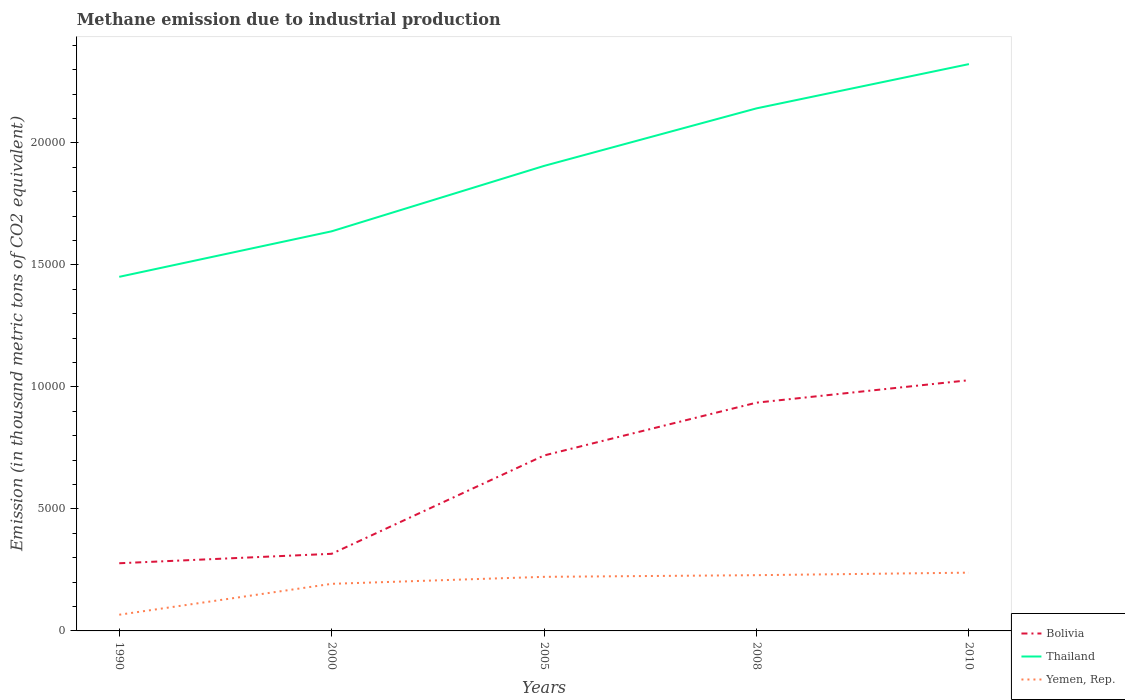Across all years, what is the maximum amount of methane emitted in Bolivia?
Provide a short and direct response. 2773.8. In which year was the amount of methane emitted in Thailand maximum?
Provide a short and direct response. 1990. What is the total amount of methane emitted in Thailand in the graph?
Keep it short and to the point. -1813.8. What is the difference between the highest and the second highest amount of methane emitted in Yemen, Rep.?
Provide a short and direct response. 1724.3. How many lines are there?
Your answer should be very brief. 3. How many years are there in the graph?
Your answer should be compact. 5. What is the difference between two consecutive major ticks on the Y-axis?
Keep it short and to the point. 5000. Does the graph contain any zero values?
Provide a succinct answer. No. Where does the legend appear in the graph?
Provide a short and direct response. Bottom right. How are the legend labels stacked?
Keep it short and to the point. Vertical. What is the title of the graph?
Your answer should be very brief. Methane emission due to industrial production. Does "Malawi" appear as one of the legend labels in the graph?
Offer a terse response. No. What is the label or title of the Y-axis?
Keep it short and to the point. Emission (in thousand metric tons of CO2 equivalent). What is the Emission (in thousand metric tons of CO2 equivalent) in Bolivia in 1990?
Give a very brief answer. 2773.8. What is the Emission (in thousand metric tons of CO2 equivalent) of Thailand in 1990?
Provide a succinct answer. 1.45e+04. What is the Emission (in thousand metric tons of CO2 equivalent) in Yemen, Rep. in 1990?
Ensure brevity in your answer.  664. What is the Emission (in thousand metric tons of CO2 equivalent) of Bolivia in 2000?
Make the answer very short. 3160.9. What is the Emission (in thousand metric tons of CO2 equivalent) of Thailand in 2000?
Your answer should be compact. 1.64e+04. What is the Emission (in thousand metric tons of CO2 equivalent) in Yemen, Rep. in 2000?
Offer a very short reply. 1930.1. What is the Emission (in thousand metric tons of CO2 equivalent) in Bolivia in 2005?
Keep it short and to the point. 7191.7. What is the Emission (in thousand metric tons of CO2 equivalent) in Thailand in 2005?
Your answer should be very brief. 1.91e+04. What is the Emission (in thousand metric tons of CO2 equivalent) of Yemen, Rep. in 2005?
Make the answer very short. 2216.9. What is the Emission (in thousand metric tons of CO2 equivalent) of Bolivia in 2008?
Give a very brief answer. 9356.3. What is the Emission (in thousand metric tons of CO2 equivalent) in Thailand in 2008?
Keep it short and to the point. 2.14e+04. What is the Emission (in thousand metric tons of CO2 equivalent) in Yemen, Rep. in 2008?
Ensure brevity in your answer.  2284.9. What is the Emission (in thousand metric tons of CO2 equivalent) in Bolivia in 2010?
Ensure brevity in your answer.  1.03e+04. What is the Emission (in thousand metric tons of CO2 equivalent) of Thailand in 2010?
Your answer should be compact. 2.32e+04. What is the Emission (in thousand metric tons of CO2 equivalent) in Yemen, Rep. in 2010?
Your response must be concise. 2388.3. Across all years, what is the maximum Emission (in thousand metric tons of CO2 equivalent) of Bolivia?
Keep it short and to the point. 1.03e+04. Across all years, what is the maximum Emission (in thousand metric tons of CO2 equivalent) in Thailand?
Keep it short and to the point. 2.32e+04. Across all years, what is the maximum Emission (in thousand metric tons of CO2 equivalent) in Yemen, Rep.?
Keep it short and to the point. 2388.3. Across all years, what is the minimum Emission (in thousand metric tons of CO2 equivalent) in Bolivia?
Provide a short and direct response. 2773.8. Across all years, what is the minimum Emission (in thousand metric tons of CO2 equivalent) of Thailand?
Keep it short and to the point. 1.45e+04. Across all years, what is the minimum Emission (in thousand metric tons of CO2 equivalent) of Yemen, Rep.?
Your answer should be very brief. 664. What is the total Emission (in thousand metric tons of CO2 equivalent) in Bolivia in the graph?
Ensure brevity in your answer.  3.28e+04. What is the total Emission (in thousand metric tons of CO2 equivalent) in Thailand in the graph?
Provide a short and direct response. 9.46e+04. What is the total Emission (in thousand metric tons of CO2 equivalent) in Yemen, Rep. in the graph?
Offer a very short reply. 9484.2. What is the difference between the Emission (in thousand metric tons of CO2 equivalent) of Bolivia in 1990 and that in 2000?
Provide a short and direct response. -387.1. What is the difference between the Emission (in thousand metric tons of CO2 equivalent) of Thailand in 1990 and that in 2000?
Keep it short and to the point. -1865.4. What is the difference between the Emission (in thousand metric tons of CO2 equivalent) in Yemen, Rep. in 1990 and that in 2000?
Your answer should be compact. -1266.1. What is the difference between the Emission (in thousand metric tons of CO2 equivalent) of Bolivia in 1990 and that in 2005?
Offer a terse response. -4417.9. What is the difference between the Emission (in thousand metric tons of CO2 equivalent) in Thailand in 1990 and that in 2005?
Offer a terse response. -4546.4. What is the difference between the Emission (in thousand metric tons of CO2 equivalent) in Yemen, Rep. in 1990 and that in 2005?
Keep it short and to the point. -1552.9. What is the difference between the Emission (in thousand metric tons of CO2 equivalent) of Bolivia in 1990 and that in 2008?
Your answer should be compact. -6582.5. What is the difference between the Emission (in thousand metric tons of CO2 equivalent) of Thailand in 1990 and that in 2008?
Make the answer very short. -6904.8. What is the difference between the Emission (in thousand metric tons of CO2 equivalent) of Yemen, Rep. in 1990 and that in 2008?
Provide a short and direct response. -1620.9. What is the difference between the Emission (in thousand metric tons of CO2 equivalent) in Bolivia in 1990 and that in 2010?
Provide a succinct answer. -7502.2. What is the difference between the Emission (in thousand metric tons of CO2 equivalent) in Thailand in 1990 and that in 2010?
Your response must be concise. -8718.6. What is the difference between the Emission (in thousand metric tons of CO2 equivalent) in Yemen, Rep. in 1990 and that in 2010?
Ensure brevity in your answer.  -1724.3. What is the difference between the Emission (in thousand metric tons of CO2 equivalent) of Bolivia in 2000 and that in 2005?
Your answer should be very brief. -4030.8. What is the difference between the Emission (in thousand metric tons of CO2 equivalent) of Thailand in 2000 and that in 2005?
Provide a short and direct response. -2681. What is the difference between the Emission (in thousand metric tons of CO2 equivalent) in Yemen, Rep. in 2000 and that in 2005?
Offer a terse response. -286.8. What is the difference between the Emission (in thousand metric tons of CO2 equivalent) in Bolivia in 2000 and that in 2008?
Offer a very short reply. -6195.4. What is the difference between the Emission (in thousand metric tons of CO2 equivalent) of Thailand in 2000 and that in 2008?
Your answer should be compact. -5039.4. What is the difference between the Emission (in thousand metric tons of CO2 equivalent) of Yemen, Rep. in 2000 and that in 2008?
Your answer should be very brief. -354.8. What is the difference between the Emission (in thousand metric tons of CO2 equivalent) of Bolivia in 2000 and that in 2010?
Ensure brevity in your answer.  -7115.1. What is the difference between the Emission (in thousand metric tons of CO2 equivalent) in Thailand in 2000 and that in 2010?
Provide a succinct answer. -6853.2. What is the difference between the Emission (in thousand metric tons of CO2 equivalent) of Yemen, Rep. in 2000 and that in 2010?
Offer a very short reply. -458.2. What is the difference between the Emission (in thousand metric tons of CO2 equivalent) in Bolivia in 2005 and that in 2008?
Keep it short and to the point. -2164.6. What is the difference between the Emission (in thousand metric tons of CO2 equivalent) in Thailand in 2005 and that in 2008?
Give a very brief answer. -2358.4. What is the difference between the Emission (in thousand metric tons of CO2 equivalent) of Yemen, Rep. in 2005 and that in 2008?
Provide a short and direct response. -68. What is the difference between the Emission (in thousand metric tons of CO2 equivalent) of Bolivia in 2005 and that in 2010?
Your answer should be compact. -3084.3. What is the difference between the Emission (in thousand metric tons of CO2 equivalent) of Thailand in 2005 and that in 2010?
Offer a terse response. -4172.2. What is the difference between the Emission (in thousand metric tons of CO2 equivalent) in Yemen, Rep. in 2005 and that in 2010?
Offer a terse response. -171.4. What is the difference between the Emission (in thousand metric tons of CO2 equivalent) of Bolivia in 2008 and that in 2010?
Your response must be concise. -919.7. What is the difference between the Emission (in thousand metric tons of CO2 equivalent) in Thailand in 2008 and that in 2010?
Keep it short and to the point. -1813.8. What is the difference between the Emission (in thousand metric tons of CO2 equivalent) of Yemen, Rep. in 2008 and that in 2010?
Offer a very short reply. -103.4. What is the difference between the Emission (in thousand metric tons of CO2 equivalent) of Bolivia in 1990 and the Emission (in thousand metric tons of CO2 equivalent) of Thailand in 2000?
Offer a terse response. -1.36e+04. What is the difference between the Emission (in thousand metric tons of CO2 equivalent) of Bolivia in 1990 and the Emission (in thousand metric tons of CO2 equivalent) of Yemen, Rep. in 2000?
Ensure brevity in your answer.  843.7. What is the difference between the Emission (in thousand metric tons of CO2 equivalent) of Thailand in 1990 and the Emission (in thousand metric tons of CO2 equivalent) of Yemen, Rep. in 2000?
Give a very brief answer. 1.26e+04. What is the difference between the Emission (in thousand metric tons of CO2 equivalent) of Bolivia in 1990 and the Emission (in thousand metric tons of CO2 equivalent) of Thailand in 2005?
Provide a succinct answer. -1.63e+04. What is the difference between the Emission (in thousand metric tons of CO2 equivalent) in Bolivia in 1990 and the Emission (in thousand metric tons of CO2 equivalent) in Yemen, Rep. in 2005?
Ensure brevity in your answer.  556.9. What is the difference between the Emission (in thousand metric tons of CO2 equivalent) in Thailand in 1990 and the Emission (in thousand metric tons of CO2 equivalent) in Yemen, Rep. in 2005?
Provide a short and direct response. 1.23e+04. What is the difference between the Emission (in thousand metric tons of CO2 equivalent) of Bolivia in 1990 and the Emission (in thousand metric tons of CO2 equivalent) of Thailand in 2008?
Offer a very short reply. -1.86e+04. What is the difference between the Emission (in thousand metric tons of CO2 equivalent) in Bolivia in 1990 and the Emission (in thousand metric tons of CO2 equivalent) in Yemen, Rep. in 2008?
Your answer should be compact. 488.9. What is the difference between the Emission (in thousand metric tons of CO2 equivalent) of Thailand in 1990 and the Emission (in thousand metric tons of CO2 equivalent) of Yemen, Rep. in 2008?
Your answer should be very brief. 1.22e+04. What is the difference between the Emission (in thousand metric tons of CO2 equivalent) of Bolivia in 1990 and the Emission (in thousand metric tons of CO2 equivalent) of Thailand in 2010?
Offer a very short reply. -2.05e+04. What is the difference between the Emission (in thousand metric tons of CO2 equivalent) of Bolivia in 1990 and the Emission (in thousand metric tons of CO2 equivalent) of Yemen, Rep. in 2010?
Your answer should be compact. 385.5. What is the difference between the Emission (in thousand metric tons of CO2 equivalent) in Thailand in 1990 and the Emission (in thousand metric tons of CO2 equivalent) in Yemen, Rep. in 2010?
Your answer should be very brief. 1.21e+04. What is the difference between the Emission (in thousand metric tons of CO2 equivalent) in Bolivia in 2000 and the Emission (in thousand metric tons of CO2 equivalent) in Thailand in 2005?
Your answer should be very brief. -1.59e+04. What is the difference between the Emission (in thousand metric tons of CO2 equivalent) in Bolivia in 2000 and the Emission (in thousand metric tons of CO2 equivalent) in Yemen, Rep. in 2005?
Keep it short and to the point. 944. What is the difference between the Emission (in thousand metric tons of CO2 equivalent) of Thailand in 2000 and the Emission (in thousand metric tons of CO2 equivalent) of Yemen, Rep. in 2005?
Ensure brevity in your answer.  1.42e+04. What is the difference between the Emission (in thousand metric tons of CO2 equivalent) in Bolivia in 2000 and the Emission (in thousand metric tons of CO2 equivalent) in Thailand in 2008?
Your answer should be very brief. -1.83e+04. What is the difference between the Emission (in thousand metric tons of CO2 equivalent) in Bolivia in 2000 and the Emission (in thousand metric tons of CO2 equivalent) in Yemen, Rep. in 2008?
Make the answer very short. 876. What is the difference between the Emission (in thousand metric tons of CO2 equivalent) in Thailand in 2000 and the Emission (in thousand metric tons of CO2 equivalent) in Yemen, Rep. in 2008?
Offer a very short reply. 1.41e+04. What is the difference between the Emission (in thousand metric tons of CO2 equivalent) in Bolivia in 2000 and the Emission (in thousand metric tons of CO2 equivalent) in Thailand in 2010?
Offer a terse response. -2.01e+04. What is the difference between the Emission (in thousand metric tons of CO2 equivalent) of Bolivia in 2000 and the Emission (in thousand metric tons of CO2 equivalent) of Yemen, Rep. in 2010?
Keep it short and to the point. 772.6. What is the difference between the Emission (in thousand metric tons of CO2 equivalent) of Thailand in 2000 and the Emission (in thousand metric tons of CO2 equivalent) of Yemen, Rep. in 2010?
Offer a very short reply. 1.40e+04. What is the difference between the Emission (in thousand metric tons of CO2 equivalent) in Bolivia in 2005 and the Emission (in thousand metric tons of CO2 equivalent) in Thailand in 2008?
Your response must be concise. -1.42e+04. What is the difference between the Emission (in thousand metric tons of CO2 equivalent) in Bolivia in 2005 and the Emission (in thousand metric tons of CO2 equivalent) in Yemen, Rep. in 2008?
Your answer should be very brief. 4906.8. What is the difference between the Emission (in thousand metric tons of CO2 equivalent) in Thailand in 2005 and the Emission (in thousand metric tons of CO2 equivalent) in Yemen, Rep. in 2008?
Your response must be concise. 1.68e+04. What is the difference between the Emission (in thousand metric tons of CO2 equivalent) of Bolivia in 2005 and the Emission (in thousand metric tons of CO2 equivalent) of Thailand in 2010?
Keep it short and to the point. -1.60e+04. What is the difference between the Emission (in thousand metric tons of CO2 equivalent) in Bolivia in 2005 and the Emission (in thousand metric tons of CO2 equivalent) in Yemen, Rep. in 2010?
Your answer should be compact. 4803.4. What is the difference between the Emission (in thousand metric tons of CO2 equivalent) in Thailand in 2005 and the Emission (in thousand metric tons of CO2 equivalent) in Yemen, Rep. in 2010?
Keep it short and to the point. 1.67e+04. What is the difference between the Emission (in thousand metric tons of CO2 equivalent) in Bolivia in 2008 and the Emission (in thousand metric tons of CO2 equivalent) in Thailand in 2010?
Offer a very short reply. -1.39e+04. What is the difference between the Emission (in thousand metric tons of CO2 equivalent) of Bolivia in 2008 and the Emission (in thousand metric tons of CO2 equivalent) of Yemen, Rep. in 2010?
Provide a succinct answer. 6968. What is the difference between the Emission (in thousand metric tons of CO2 equivalent) in Thailand in 2008 and the Emission (in thousand metric tons of CO2 equivalent) in Yemen, Rep. in 2010?
Make the answer very short. 1.90e+04. What is the average Emission (in thousand metric tons of CO2 equivalent) in Bolivia per year?
Your answer should be compact. 6551.74. What is the average Emission (in thousand metric tons of CO2 equivalent) in Thailand per year?
Make the answer very short. 1.89e+04. What is the average Emission (in thousand metric tons of CO2 equivalent) in Yemen, Rep. per year?
Make the answer very short. 1896.84. In the year 1990, what is the difference between the Emission (in thousand metric tons of CO2 equivalent) of Bolivia and Emission (in thousand metric tons of CO2 equivalent) of Thailand?
Your answer should be compact. -1.17e+04. In the year 1990, what is the difference between the Emission (in thousand metric tons of CO2 equivalent) in Bolivia and Emission (in thousand metric tons of CO2 equivalent) in Yemen, Rep.?
Your response must be concise. 2109.8. In the year 1990, what is the difference between the Emission (in thousand metric tons of CO2 equivalent) of Thailand and Emission (in thousand metric tons of CO2 equivalent) of Yemen, Rep.?
Provide a short and direct response. 1.38e+04. In the year 2000, what is the difference between the Emission (in thousand metric tons of CO2 equivalent) of Bolivia and Emission (in thousand metric tons of CO2 equivalent) of Thailand?
Give a very brief answer. -1.32e+04. In the year 2000, what is the difference between the Emission (in thousand metric tons of CO2 equivalent) of Bolivia and Emission (in thousand metric tons of CO2 equivalent) of Yemen, Rep.?
Your response must be concise. 1230.8. In the year 2000, what is the difference between the Emission (in thousand metric tons of CO2 equivalent) of Thailand and Emission (in thousand metric tons of CO2 equivalent) of Yemen, Rep.?
Your answer should be compact. 1.44e+04. In the year 2005, what is the difference between the Emission (in thousand metric tons of CO2 equivalent) of Bolivia and Emission (in thousand metric tons of CO2 equivalent) of Thailand?
Keep it short and to the point. -1.19e+04. In the year 2005, what is the difference between the Emission (in thousand metric tons of CO2 equivalent) of Bolivia and Emission (in thousand metric tons of CO2 equivalent) of Yemen, Rep.?
Make the answer very short. 4974.8. In the year 2005, what is the difference between the Emission (in thousand metric tons of CO2 equivalent) of Thailand and Emission (in thousand metric tons of CO2 equivalent) of Yemen, Rep.?
Give a very brief answer. 1.68e+04. In the year 2008, what is the difference between the Emission (in thousand metric tons of CO2 equivalent) of Bolivia and Emission (in thousand metric tons of CO2 equivalent) of Thailand?
Give a very brief answer. -1.21e+04. In the year 2008, what is the difference between the Emission (in thousand metric tons of CO2 equivalent) in Bolivia and Emission (in thousand metric tons of CO2 equivalent) in Yemen, Rep.?
Your answer should be very brief. 7071.4. In the year 2008, what is the difference between the Emission (in thousand metric tons of CO2 equivalent) in Thailand and Emission (in thousand metric tons of CO2 equivalent) in Yemen, Rep.?
Give a very brief answer. 1.91e+04. In the year 2010, what is the difference between the Emission (in thousand metric tons of CO2 equivalent) in Bolivia and Emission (in thousand metric tons of CO2 equivalent) in Thailand?
Offer a very short reply. -1.30e+04. In the year 2010, what is the difference between the Emission (in thousand metric tons of CO2 equivalent) of Bolivia and Emission (in thousand metric tons of CO2 equivalent) of Yemen, Rep.?
Your answer should be very brief. 7887.7. In the year 2010, what is the difference between the Emission (in thousand metric tons of CO2 equivalent) in Thailand and Emission (in thousand metric tons of CO2 equivalent) in Yemen, Rep.?
Your answer should be very brief. 2.08e+04. What is the ratio of the Emission (in thousand metric tons of CO2 equivalent) in Bolivia in 1990 to that in 2000?
Ensure brevity in your answer.  0.88. What is the ratio of the Emission (in thousand metric tons of CO2 equivalent) in Thailand in 1990 to that in 2000?
Offer a very short reply. 0.89. What is the ratio of the Emission (in thousand metric tons of CO2 equivalent) in Yemen, Rep. in 1990 to that in 2000?
Your answer should be very brief. 0.34. What is the ratio of the Emission (in thousand metric tons of CO2 equivalent) in Bolivia in 1990 to that in 2005?
Make the answer very short. 0.39. What is the ratio of the Emission (in thousand metric tons of CO2 equivalent) in Thailand in 1990 to that in 2005?
Your answer should be very brief. 0.76. What is the ratio of the Emission (in thousand metric tons of CO2 equivalent) in Yemen, Rep. in 1990 to that in 2005?
Your answer should be compact. 0.3. What is the ratio of the Emission (in thousand metric tons of CO2 equivalent) in Bolivia in 1990 to that in 2008?
Keep it short and to the point. 0.3. What is the ratio of the Emission (in thousand metric tons of CO2 equivalent) in Thailand in 1990 to that in 2008?
Offer a terse response. 0.68. What is the ratio of the Emission (in thousand metric tons of CO2 equivalent) in Yemen, Rep. in 1990 to that in 2008?
Your answer should be compact. 0.29. What is the ratio of the Emission (in thousand metric tons of CO2 equivalent) of Bolivia in 1990 to that in 2010?
Your response must be concise. 0.27. What is the ratio of the Emission (in thousand metric tons of CO2 equivalent) in Thailand in 1990 to that in 2010?
Your answer should be compact. 0.62. What is the ratio of the Emission (in thousand metric tons of CO2 equivalent) of Yemen, Rep. in 1990 to that in 2010?
Your response must be concise. 0.28. What is the ratio of the Emission (in thousand metric tons of CO2 equivalent) of Bolivia in 2000 to that in 2005?
Give a very brief answer. 0.44. What is the ratio of the Emission (in thousand metric tons of CO2 equivalent) of Thailand in 2000 to that in 2005?
Ensure brevity in your answer.  0.86. What is the ratio of the Emission (in thousand metric tons of CO2 equivalent) of Yemen, Rep. in 2000 to that in 2005?
Your answer should be very brief. 0.87. What is the ratio of the Emission (in thousand metric tons of CO2 equivalent) of Bolivia in 2000 to that in 2008?
Keep it short and to the point. 0.34. What is the ratio of the Emission (in thousand metric tons of CO2 equivalent) of Thailand in 2000 to that in 2008?
Ensure brevity in your answer.  0.76. What is the ratio of the Emission (in thousand metric tons of CO2 equivalent) of Yemen, Rep. in 2000 to that in 2008?
Keep it short and to the point. 0.84. What is the ratio of the Emission (in thousand metric tons of CO2 equivalent) in Bolivia in 2000 to that in 2010?
Provide a succinct answer. 0.31. What is the ratio of the Emission (in thousand metric tons of CO2 equivalent) in Thailand in 2000 to that in 2010?
Your answer should be compact. 0.7. What is the ratio of the Emission (in thousand metric tons of CO2 equivalent) of Yemen, Rep. in 2000 to that in 2010?
Provide a short and direct response. 0.81. What is the ratio of the Emission (in thousand metric tons of CO2 equivalent) in Bolivia in 2005 to that in 2008?
Your response must be concise. 0.77. What is the ratio of the Emission (in thousand metric tons of CO2 equivalent) of Thailand in 2005 to that in 2008?
Your response must be concise. 0.89. What is the ratio of the Emission (in thousand metric tons of CO2 equivalent) of Yemen, Rep. in 2005 to that in 2008?
Give a very brief answer. 0.97. What is the ratio of the Emission (in thousand metric tons of CO2 equivalent) of Bolivia in 2005 to that in 2010?
Your answer should be compact. 0.7. What is the ratio of the Emission (in thousand metric tons of CO2 equivalent) of Thailand in 2005 to that in 2010?
Make the answer very short. 0.82. What is the ratio of the Emission (in thousand metric tons of CO2 equivalent) in Yemen, Rep. in 2005 to that in 2010?
Provide a succinct answer. 0.93. What is the ratio of the Emission (in thousand metric tons of CO2 equivalent) of Bolivia in 2008 to that in 2010?
Ensure brevity in your answer.  0.91. What is the ratio of the Emission (in thousand metric tons of CO2 equivalent) in Thailand in 2008 to that in 2010?
Give a very brief answer. 0.92. What is the ratio of the Emission (in thousand metric tons of CO2 equivalent) in Yemen, Rep. in 2008 to that in 2010?
Your answer should be compact. 0.96. What is the difference between the highest and the second highest Emission (in thousand metric tons of CO2 equivalent) of Bolivia?
Provide a short and direct response. 919.7. What is the difference between the highest and the second highest Emission (in thousand metric tons of CO2 equivalent) of Thailand?
Give a very brief answer. 1813.8. What is the difference between the highest and the second highest Emission (in thousand metric tons of CO2 equivalent) of Yemen, Rep.?
Your answer should be compact. 103.4. What is the difference between the highest and the lowest Emission (in thousand metric tons of CO2 equivalent) of Bolivia?
Offer a very short reply. 7502.2. What is the difference between the highest and the lowest Emission (in thousand metric tons of CO2 equivalent) of Thailand?
Your answer should be compact. 8718.6. What is the difference between the highest and the lowest Emission (in thousand metric tons of CO2 equivalent) of Yemen, Rep.?
Ensure brevity in your answer.  1724.3. 